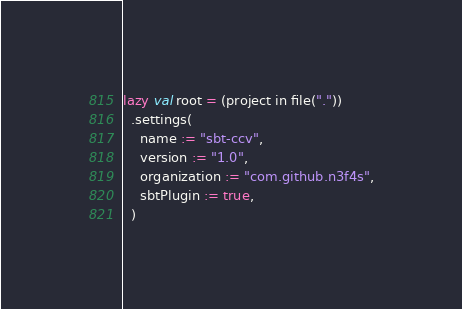Convert code to text. <code><loc_0><loc_0><loc_500><loc_500><_Scala_>lazy val root = (project in file("."))
  .settings(
    name := "sbt-ccv",
    version := "1.0",
    organization := "com.github.n3f4s",
    sbtPlugin := true,
  )
</code> 